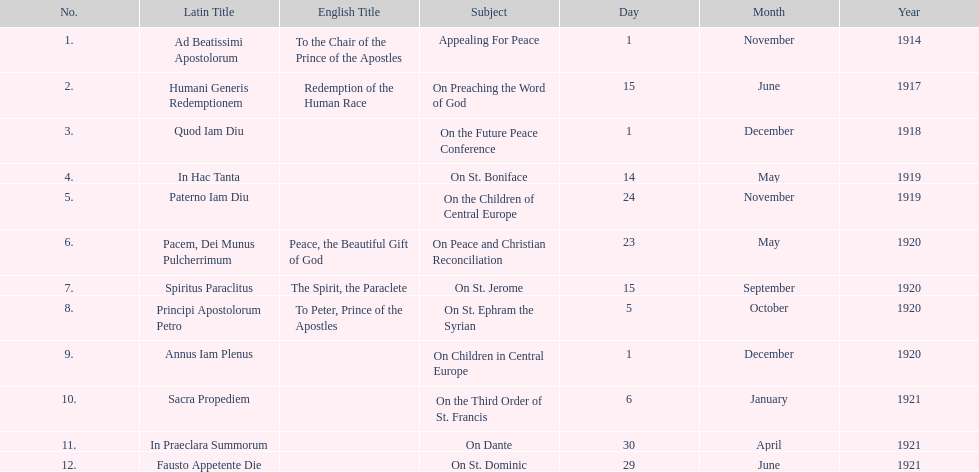After 1 december 1918 when was the next encyclical? 14 May 1919. 